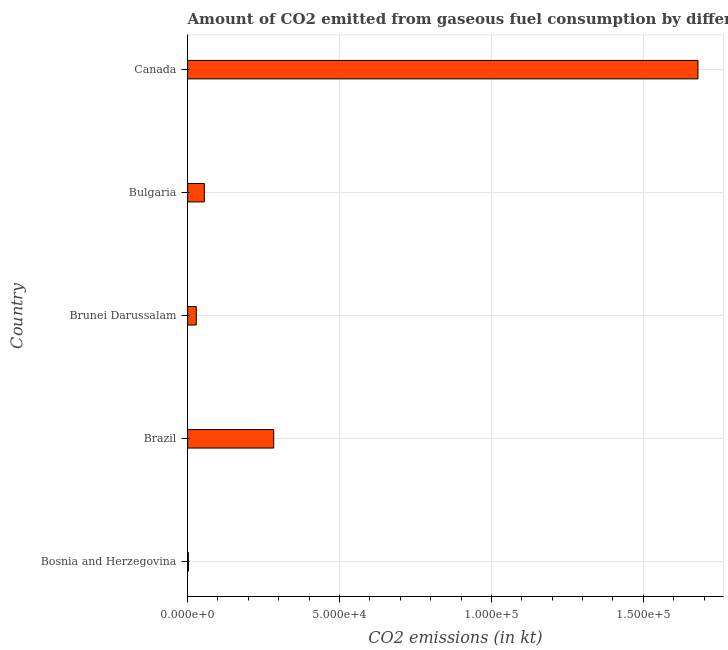Does the graph contain any zero values?
Provide a succinct answer. No. What is the title of the graph?
Ensure brevity in your answer.  Amount of CO2 emitted from gaseous fuel consumption by different countries in 2002. What is the label or title of the X-axis?
Your response must be concise. CO2 emissions (in kt). What is the label or title of the Y-axis?
Ensure brevity in your answer.  Country. What is the co2 emissions from gaseous fuel consumption in Canada?
Provide a succinct answer. 1.68e+05. Across all countries, what is the maximum co2 emissions from gaseous fuel consumption?
Provide a succinct answer. 1.68e+05. Across all countries, what is the minimum co2 emissions from gaseous fuel consumption?
Give a very brief answer. 282.36. In which country was the co2 emissions from gaseous fuel consumption minimum?
Make the answer very short. Bosnia and Herzegovina. What is the sum of the co2 emissions from gaseous fuel consumption?
Ensure brevity in your answer.  2.05e+05. What is the difference between the co2 emissions from gaseous fuel consumption in Bosnia and Herzegovina and Brazil?
Offer a terse response. -2.81e+04. What is the average co2 emissions from gaseous fuel consumption per country?
Provide a succinct answer. 4.10e+04. What is the median co2 emissions from gaseous fuel consumption?
Make the answer very short. 5507.83. What is the ratio of the co2 emissions from gaseous fuel consumption in Bosnia and Herzegovina to that in Brazil?
Ensure brevity in your answer.  0.01. Is the co2 emissions from gaseous fuel consumption in Bosnia and Herzegovina less than that in Brazil?
Keep it short and to the point. Yes. What is the difference between the highest and the second highest co2 emissions from gaseous fuel consumption?
Provide a short and direct response. 1.40e+05. Is the sum of the co2 emissions from gaseous fuel consumption in Bosnia and Herzegovina and Bulgaria greater than the maximum co2 emissions from gaseous fuel consumption across all countries?
Offer a terse response. No. What is the difference between the highest and the lowest co2 emissions from gaseous fuel consumption?
Provide a short and direct response. 1.68e+05. How many countries are there in the graph?
Give a very brief answer. 5. What is the difference between two consecutive major ticks on the X-axis?
Your response must be concise. 5.00e+04. What is the CO2 emissions (in kt) in Bosnia and Herzegovina?
Your answer should be very brief. 282.36. What is the CO2 emissions (in kt) in Brazil?
Ensure brevity in your answer.  2.83e+04. What is the CO2 emissions (in kt) in Brunei Darussalam?
Give a very brief answer. 2852.93. What is the CO2 emissions (in kt) in Bulgaria?
Your answer should be very brief. 5507.83. What is the CO2 emissions (in kt) of Canada?
Your answer should be compact. 1.68e+05. What is the difference between the CO2 emissions (in kt) in Bosnia and Herzegovina and Brazil?
Provide a succinct answer. -2.81e+04. What is the difference between the CO2 emissions (in kt) in Bosnia and Herzegovina and Brunei Darussalam?
Provide a succinct answer. -2570.57. What is the difference between the CO2 emissions (in kt) in Bosnia and Herzegovina and Bulgaria?
Provide a succinct answer. -5225.48. What is the difference between the CO2 emissions (in kt) in Bosnia and Herzegovina and Canada?
Your response must be concise. -1.68e+05. What is the difference between the CO2 emissions (in kt) in Brazil and Brunei Darussalam?
Give a very brief answer. 2.55e+04. What is the difference between the CO2 emissions (in kt) in Brazil and Bulgaria?
Provide a short and direct response. 2.28e+04. What is the difference between the CO2 emissions (in kt) in Brazil and Canada?
Make the answer very short. -1.40e+05. What is the difference between the CO2 emissions (in kt) in Brunei Darussalam and Bulgaria?
Offer a terse response. -2654.91. What is the difference between the CO2 emissions (in kt) in Brunei Darussalam and Canada?
Offer a terse response. -1.65e+05. What is the difference between the CO2 emissions (in kt) in Bulgaria and Canada?
Ensure brevity in your answer.  -1.62e+05. What is the ratio of the CO2 emissions (in kt) in Bosnia and Herzegovina to that in Brazil?
Ensure brevity in your answer.  0.01. What is the ratio of the CO2 emissions (in kt) in Bosnia and Herzegovina to that in Brunei Darussalam?
Make the answer very short. 0.1. What is the ratio of the CO2 emissions (in kt) in Bosnia and Herzegovina to that in Bulgaria?
Ensure brevity in your answer.  0.05. What is the ratio of the CO2 emissions (in kt) in Bosnia and Herzegovina to that in Canada?
Keep it short and to the point. 0. What is the ratio of the CO2 emissions (in kt) in Brazil to that in Brunei Darussalam?
Your answer should be very brief. 9.94. What is the ratio of the CO2 emissions (in kt) in Brazil to that in Bulgaria?
Ensure brevity in your answer.  5.15. What is the ratio of the CO2 emissions (in kt) in Brazil to that in Canada?
Provide a succinct answer. 0.17. What is the ratio of the CO2 emissions (in kt) in Brunei Darussalam to that in Bulgaria?
Your response must be concise. 0.52. What is the ratio of the CO2 emissions (in kt) in Brunei Darussalam to that in Canada?
Ensure brevity in your answer.  0.02. What is the ratio of the CO2 emissions (in kt) in Bulgaria to that in Canada?
Your answer should be very brief. 0.03. 